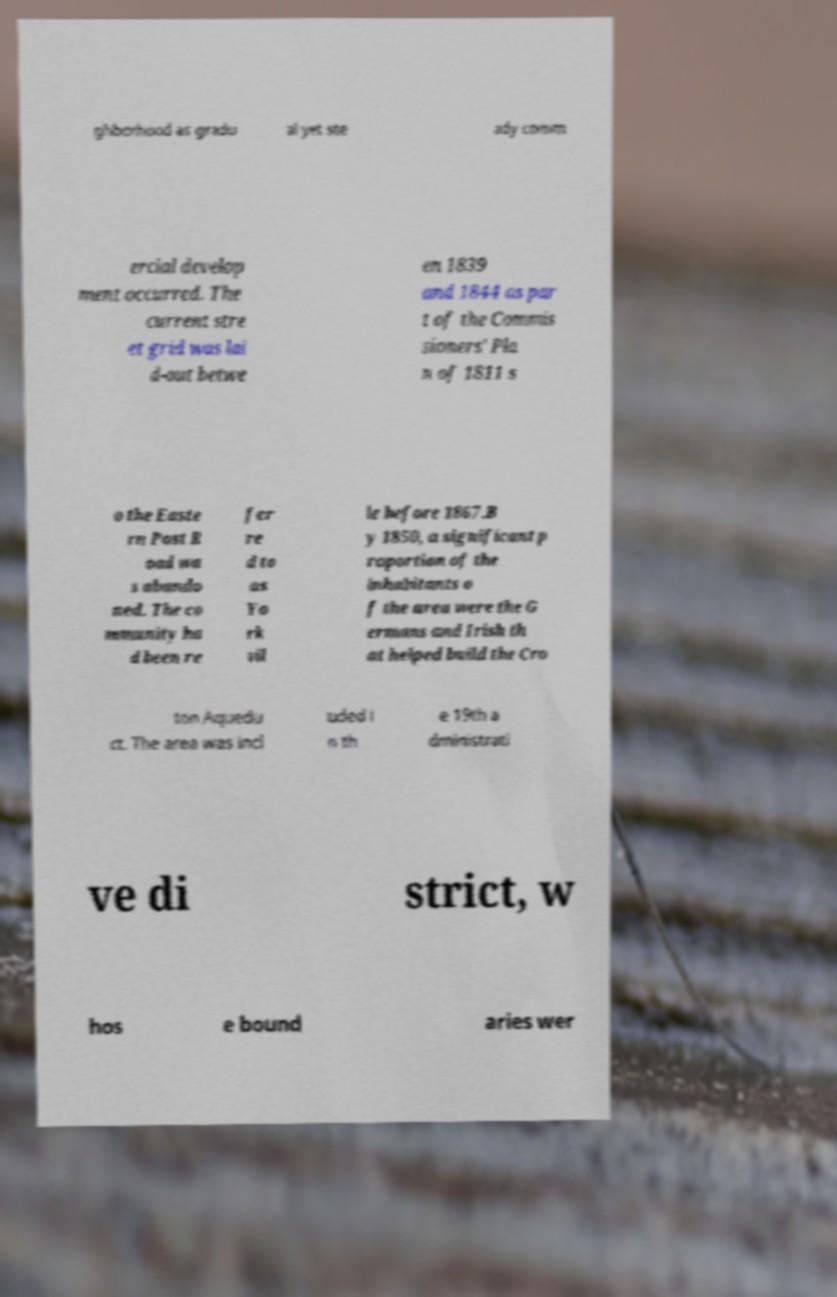Please read and relay the text visible in this image. What does it say? ghborhood as gradu al yet ste ady comm ercial develop ment occurred. The current stre et grid was lai d-out betwe en 1839 and 1844 as par t of the Commis sioners' Pla n of 1811 s o the Easte rn Post R oad wa s abando ned. The co mmunity ha d been re fer re d to as Yo rk vil le before 1867.B y 1850, a significant p roportion of the inhabitants o f the area were the G ermans and Irish th at helped build the Cro ton Aquedu ct. The area was incl uded i n th e 19th a dministrati ve di strict, w hos e bound aries wer 